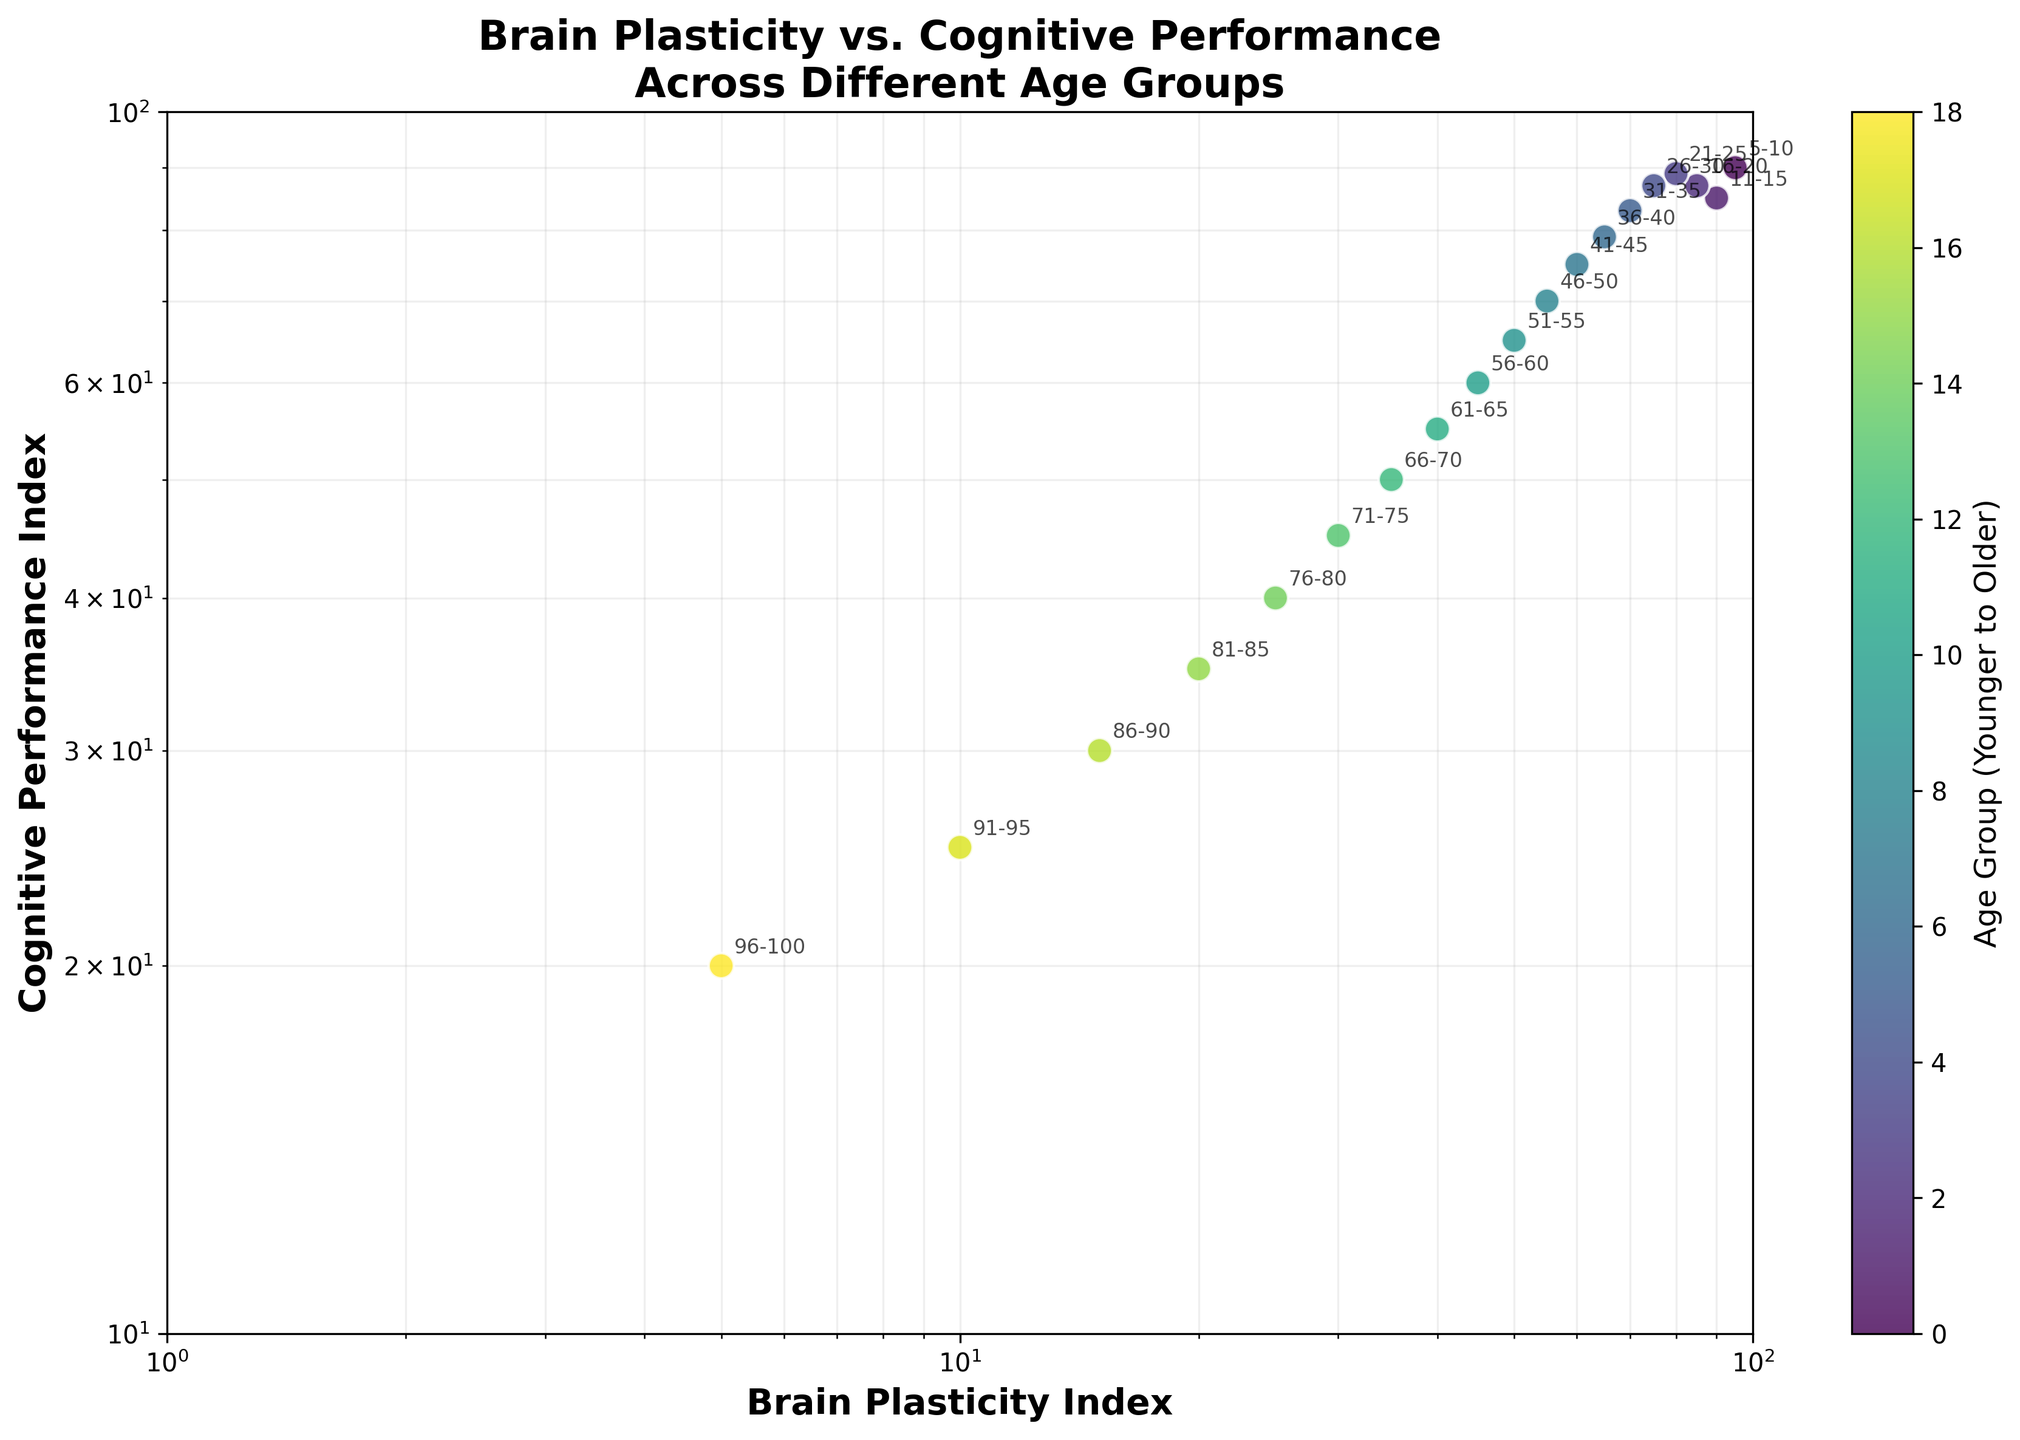What's the title of the plot? The title is usually displayed at the top of the figure. In this case, the title of the plot is "Brain Plasticity vs. Cognitive Performance Across Different Age Groups".
Answer: Brain Plasticity vs. Cognitive Performance Across Different Age Groups How many age groups are represented in the scatter plot? By counting the number of data points or labels on the plot, we can determine how many age groups are represented. There are 19 age groups in the scatter plot.
Answer: 19 Which age group has the highest Brain Plasticity Index? We need to look at the data points on the x-axis to find the highest value. The age group with the highest Brain Plasticity Index is 5-10, with a Brain Plasticity Index of 95.
Answer: 5-10 What is the Cognitive Performance Index for the age group 56-60? We need to find the labeled data point for the age group 56-60 and read the corresponding y-axis value. The Cognitive Performance Index for this age group is 60.
Answer: 60 Is the Cognitive Performance Index generally higher for younger age groups or older age groups? By observing the trend in the scatter plot, we see that younger age groups tend to have higher Cognitive Performance Indices, while older age groups have lower indices.
Answer: Younger age groups At which Brain Plasticity Index does the Cognitive Performance Index start to fall below 50? We need to identify the point on the x-axis where the y-axis value drops below 50. The Brain Plasticity Index at which this occurs is at the age group 66-70, with a Brain Plasticity Index of 35.
Answer: 35 What is the range of Cognitive Performance Index values represented in the plot? The y-axis values range from the minimum to the maximum Cognitive Performance Index. The minimum value is 20 (for 96-100 age group) and the maximum is 90 (for 5-10 age group).
Answer: 20 to 90 Which age group has the lowest Cognitive Performance Index, and what is its value? We look for the data point with the lowest y-axis value, which is the age group 96-100, with a Cognitive Performance Index of 20.
Answer: 96-100, 20 Is there a general trend between Brain Plasticity Index and Cognitive Performance Index as age increases? Observing the scatter plot, as the Brain Plasticity Index decreases (and hence age increases), the Cognitive Performance Index generally decreases as well, indicating a positive correlation between the two.
Answer: Yes, they both decrease Do any age groups have a Cognitive Performance Index greater than 75 but less than 90? We look for data points with y-axis values between 75 and 90. The age groups 5-10, 11-15, 16-20, 21-25, and 26-30 have Cognitive Performance Indices within this range.
Answer: 5-10, 11-15, 16-20, 21-25, 26-30 